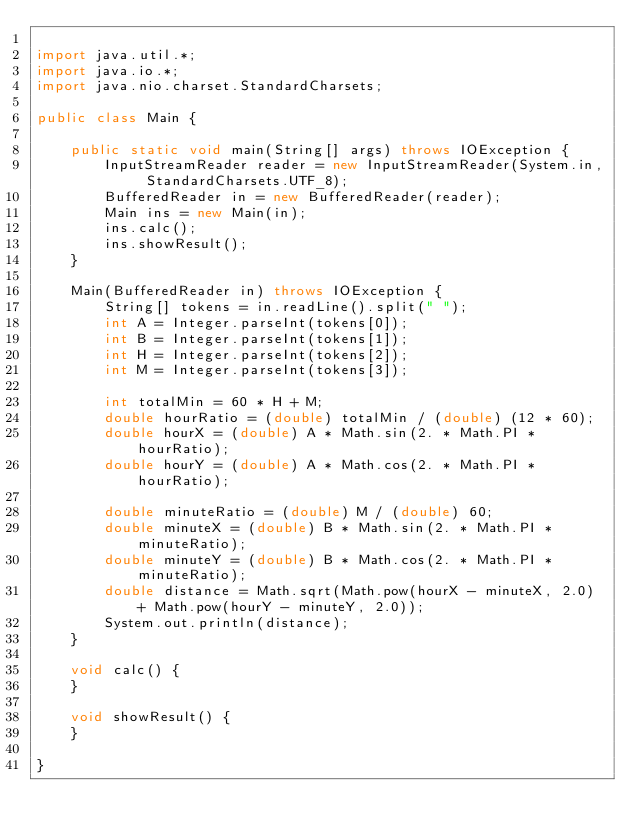Convert code to text. <code><loc_0><loc_0><loc_500><loc_500><_Java_>
import java.util.*;
import java.io.*;
import java.nio.charset.StandardCharsets;

public class Main {

	public static void main(String[] args) throws IOException {
		InputStreamReader reader = new InputStreamReader(System.in, StandardCharsets.UTF_8);
		BufferedReader in = new BufferedReader(reader);
		Main ins = new Main(in);
		ins.calc();
		ins.showResult();
	}

	Main(BufferedReader in) throws IOException {
		String[] tokens = in.readLine().split(" ");
		int A = Integer.parseInt(tokens[0]);
		int B = Integer.parseInt(tokens[1]);
		int H = Integer.parseInt(tokens[2]);
		int M = Integer.parseInt(tokens[3]);

		int totalMin = 60 * H + M;
		double hourRatio = (double) totalMin / (double) (12 * 60);
		double hourX = (double) A * Math.sin(2. * Math.PI * hourRatio);
		double hourY = (double) A * Math.cos(2. * Math.PI * hourRatio);

		double minuteRatio = (double) M / (double) 60;
		double minuteX = (double) B * Math.sin(2. * Math.PI * minuteRatio);
		double minuteY = (double) B * Math.cos(2. * Math.PI * minuteRatio);
		double distance = Math.sqrt(Math.pow(hourX - minuteX, 2.0) + Math.pow(hourY - minuteY, 2.0));
		System.out.println(distance);
	}

	void calc() {
	}

	void showResult() {
	}

}
</code> 